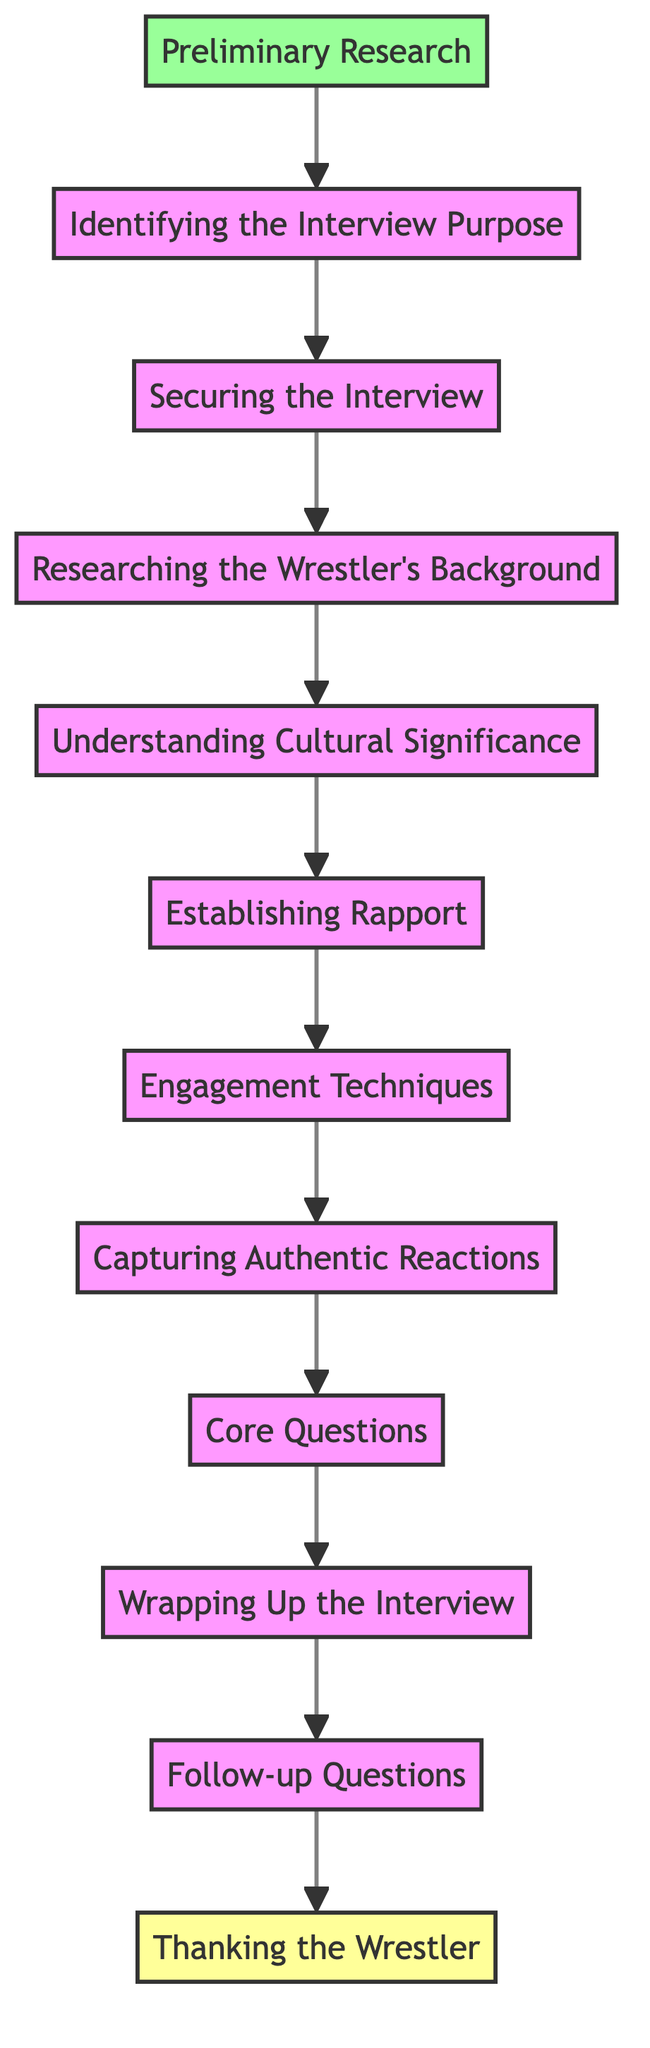What is the last step in the interview process? The last step in the interview process as shown in the flow chart is "Thanking the Wrestler," which is the final node connected to "Follow-up Questions."
Answer: Thanking the Wrestler How many total steps are there in the interview process? By counting the nodes in the flow chart, there are eleven distinct steps, starting from "Preliminary Research" to "Thanking the Wrestler."
Answer: Eleven What precedes "Capturing Authentic Reactions"? According to the flow chart, "Engagement Techniques" is the step that directly precedes "Capturing Authentic Reactions."
Answer: Engagement Techniques What is the purpose of "Establishing Rapport"? The flow chart indicates that the purpose of "Establishing Rapport" is to make the wrestler comfortable by starting with casual conversation.
Answer: To make the wrestler comfortable Which step involves asking core questions? "Core Questions" is the specific step in the flow chart where pre-prepared questions are asked regarding sumo matches and training.
Answer: Core Questions Which step comes immediately after "Wrapping Up the Interview"? The step that follows "Wrapping Up the Interview" is "Follow-up Questions," indicating the next part of the process.
Answer: Follow-up Questions What is the first step in conducting an interview with a sumo wrestler? The first step in the process, as outlined in the flow chart, is "Preliminary Research."
Answer: Preliminary Research What step directly connects "Understanding Cultural Significance" and "Establishing Rapport"? The flow chart shows that "Understanding Cultural Significance" connects to "Establishing Rapport" directly, indicating a sequence in the interview preparation.
Answer: Establishing Rapport What is one of the aims of "Thanking the Wrestler"? The aim of "Thanking the Wrestler," based on the flow chart, is to express gratitude for their time and insights during the interview.
Answer: To express gratitude 